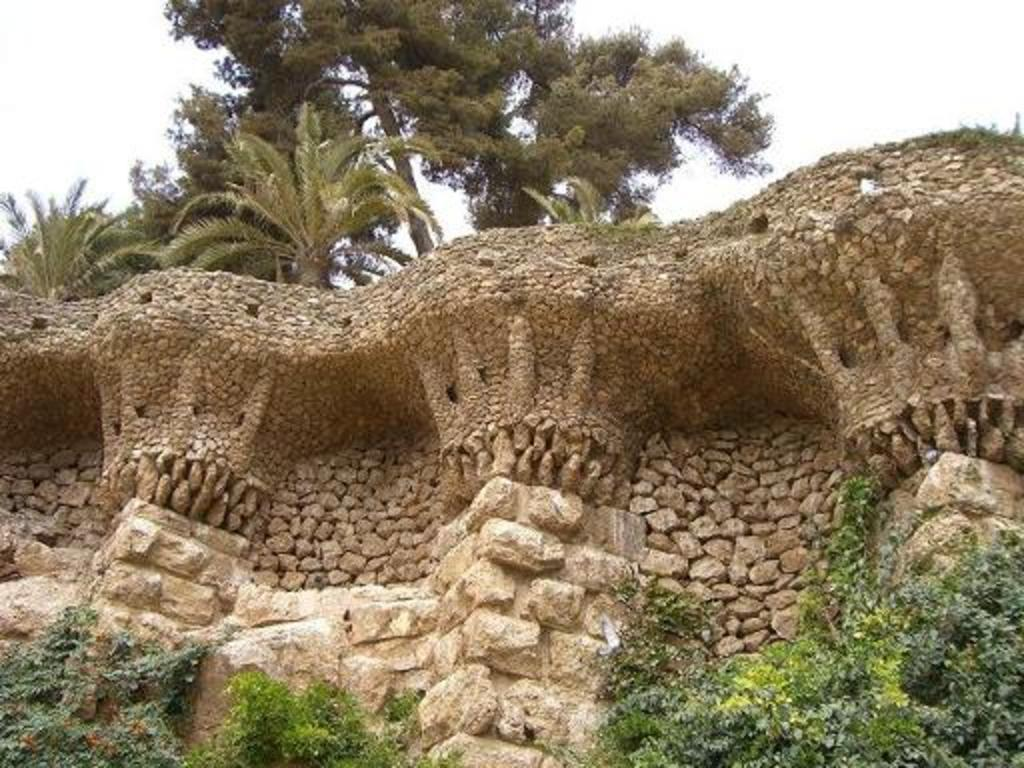What is located in the middle of the image? There is a wall in the middle of the image. What can be seen at the bottom of the image? There are plants and stones at the bottom of the image. What is visible at the top of the image? There are trees and the sky at the top of the image. Can you tell me how many pencils are standing in the vase in the image? There is no vase or pencil present in the image. What type of headwear is the person wearing in the image? There is no person or headwear visible in the image. 